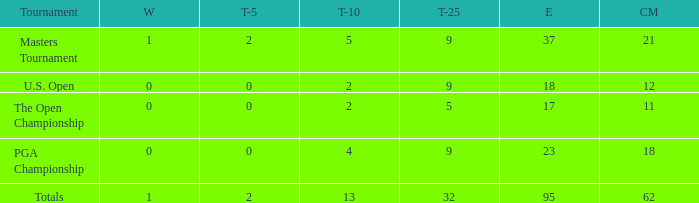What is the lowest top 5 winners with less than 0? None. 